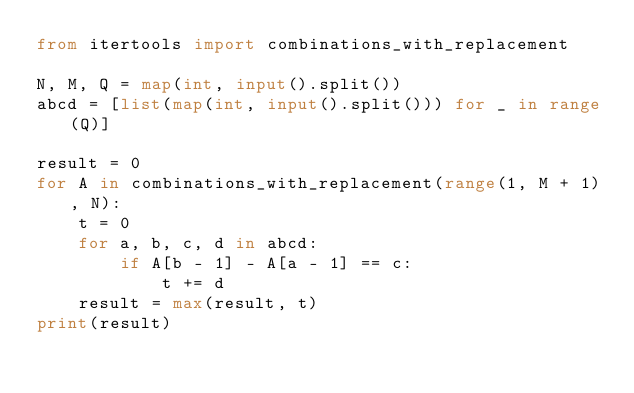Convert code to text. <code><loc_0><loc_0><loc_500><loc_500><_Python_>from itertools import combinations_with_replacement

N, M, Q = map(int, input().split())
abcd = [list(map(int, input().split())) for _ in range(Q)]

result = 0
for A in combinations_with_replacement(range(1, M + 1), N):
    t = 0
    for a, b, c, d in abcd:
        if A[b - 1] - A[a - 1] == c:
            t += d
    result = max(result, t)
print(result)
</code> 